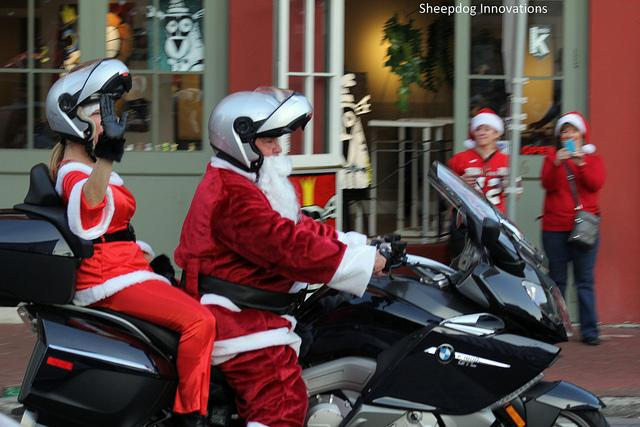Who is riding on the motorcycle?

Choices:
A) easter bunny
B) freddy krueger
C) jason vorhees
D) santa claus santa claus 